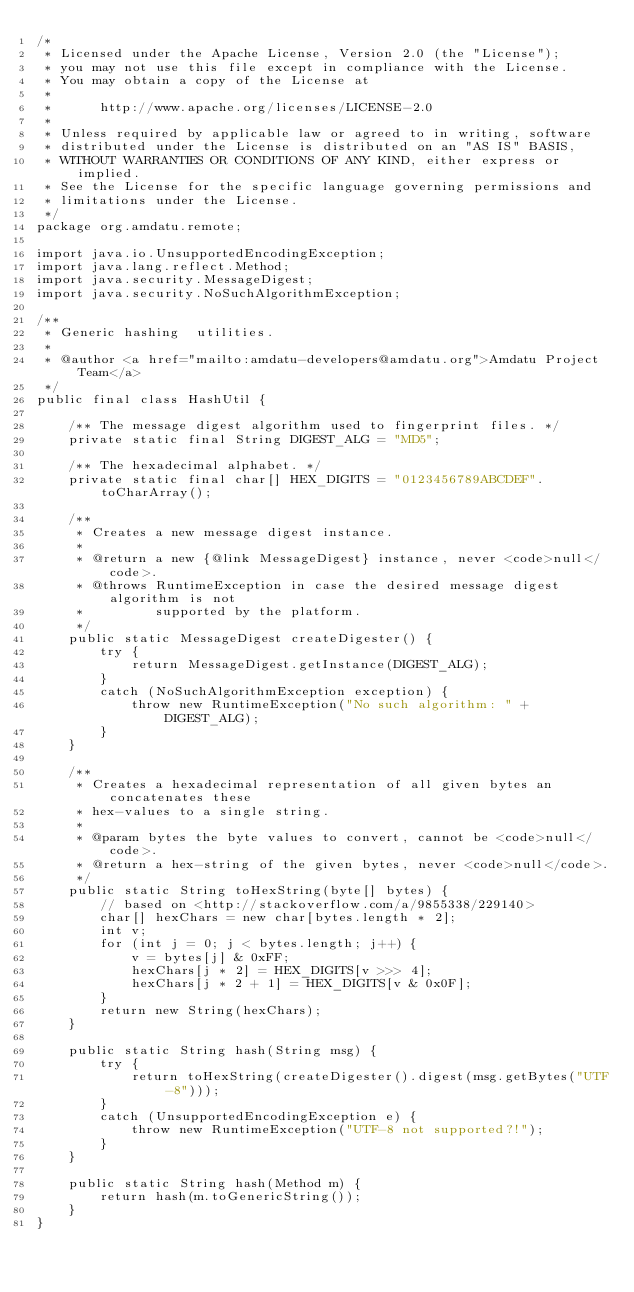<code> <loc_0><loc_0><loc_500><loc_500><_Java_>/*
 * Licensed under the Apache License, Version 2.0 (the "License");
 * you may not use this file except in compliance with the License.
 * You may obtain a copy of the License at
 *
 *      http://www.apache.org/licenses/LICENSE-2.0
 *
 * Unless required by applicable law or agreed to in writing, software
 * distributed under the License is distributed on an "AS IS" BASIS,
 * WITHOUT WARRANTIES OR CONDITIONS OF ANY KIND, either express or implied.
 * See the License for the specific language governing permissions and
 * limitations under the License.
 */
package org.amdatu.remote;

import java.io.UnsupportedEncodingException;
import java.lang.reflect.Method;
import java.security.MessageDigest;
import java.security.NoSuchAlgorithmException;

/**
 * Generic hashing  utilities.
 * 
 * @author <a href="mailto:amdatu-developers@amdatu.org">Amdatu Project Team</a>
 */
public final class HashUtil {

    /** The message digest algorithm used to fingerprint files. */
    private static final String DIGEST_ALG = "MD5";

    /** The hexadecimal alphabet. */
    private static final char[] HEX_DIGITS = "0123456789ABCDEF".toCharArray();

    /**
     * Creates a new message digest instance.
     * 
     * @return a new {@link MessageDigest} instance, never <code>null</code>.
     * @throws RuntimeException in case the desired message digest algorithm is not
     *         supported by the platform.
     */
    public static MessageDigest createDigester() {
        try {
            return MessageDigest.getInstance(DIGEST_ALG);
        }
        catch (NoSuchAlgorithmException exception) {
            throw new RuntimeException("No such algorithm: " + DIGEST_ALG);
        }
    }

    /**
     * Creates a hexadecimal representation of all given bytes an concatenates these
     * hex-values to a single string.
     * 
     * @param bytes the byte values to convert, cannot be <code>null</code>.
     * @return a hex-string of the given bytes, never <code>null</code>.
     */
    public static String toHexString(byte[] bytes) {
        // based on <http://stackoverflow.com/a/9855338/229140>
        char[] hexChars = new char[bytes.length * 2];
        int v;
        for (int j = 0; j < bytes.length; j++) {
            v = bytes[j] & 0xFF;
            hexChars[j * 2] = HEX_DIGITS[v >>> 4];
            hexChars[j * 2 + 1] = HEX_DIGITS[v & 0x0F];
        }
        return new String(hexChars);
    }

    public static String hash(String msg) {
        try {
            return toHexString(createDigester().digest(msg.getBytes("UTF-8")));
        }
        catch (UnsupportedEncodingException e) {
            throw new RuntimeException("UTF-8 not supported?!");
        }
    }

    public static String hash(Method m) {
        return hash(m.toGenericString());
    }
}
</code> 